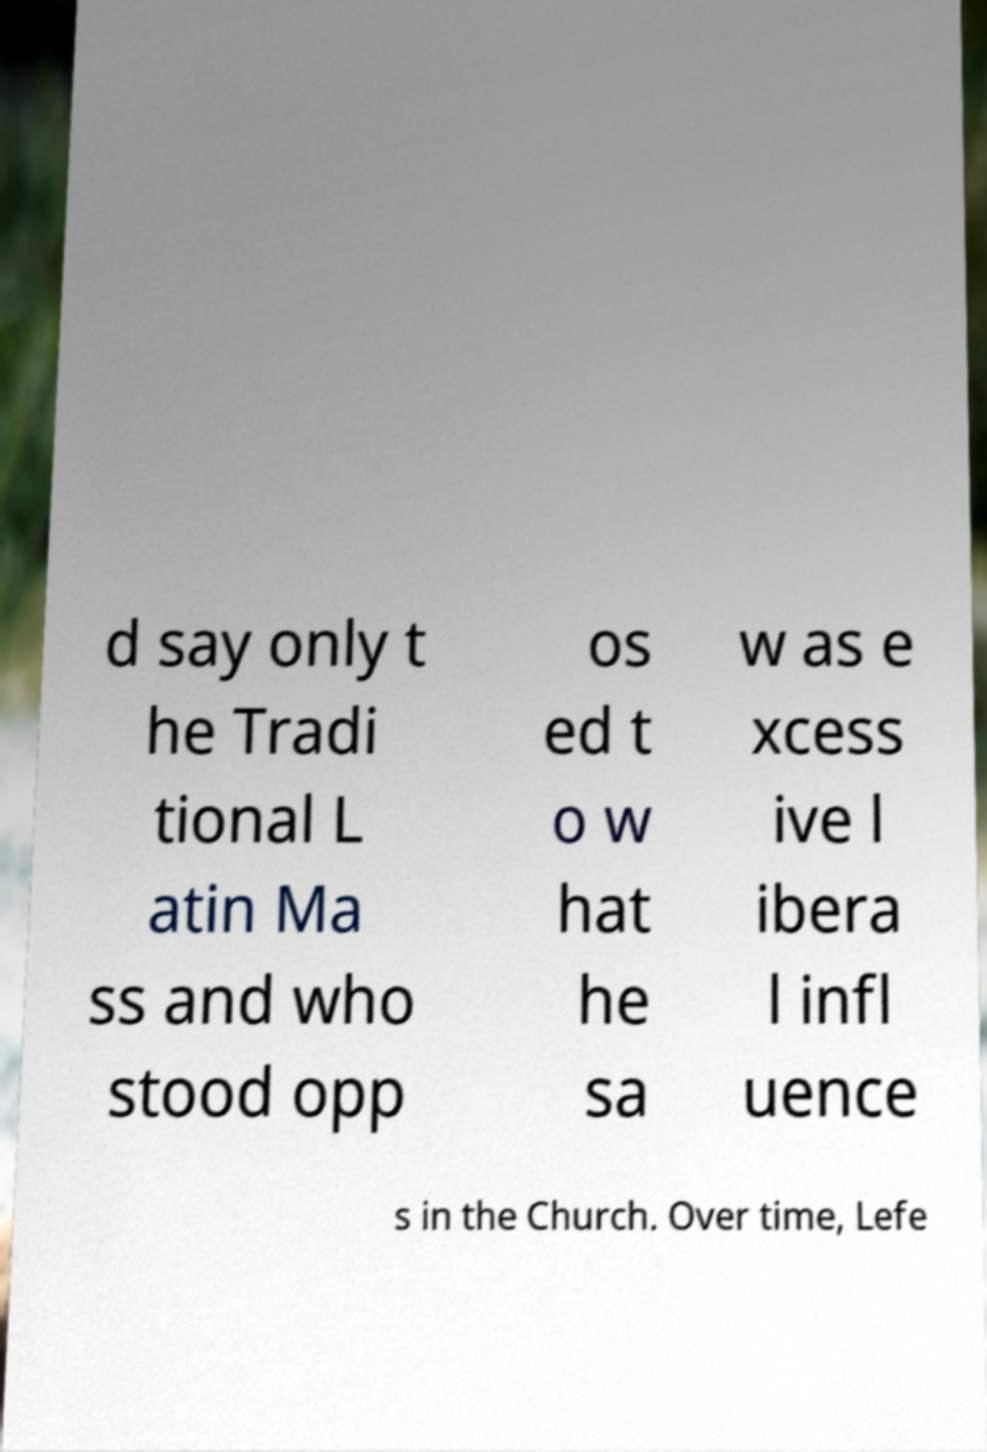Can you accurately transcribe the text from the provided image for me? d say only t he Tradi tional L atin Ma ss and who stood opp os ed t o w hat he sa w as e xcess ive l ibera l infl uence s in the Church. Over time, Lefe 